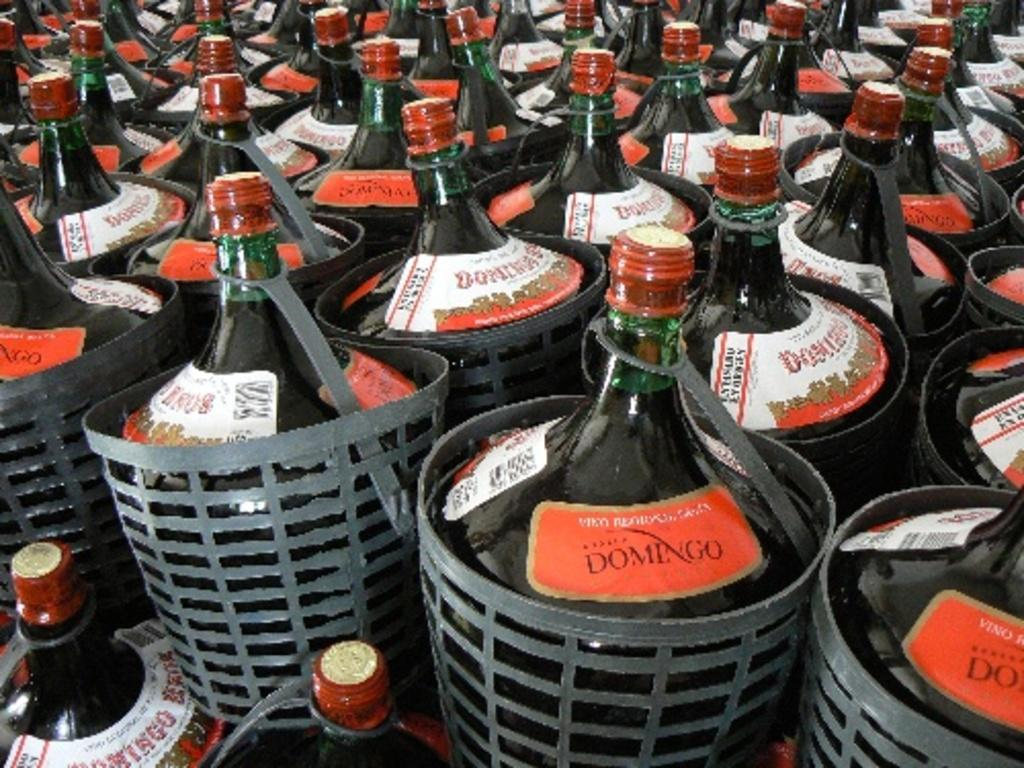<image>
Write a terse but informative summary of the picture. Several gallon size bottles of Domingo sit in baskets 